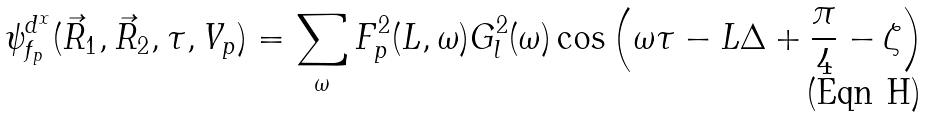<formula> <loc_0><loc_0><loc_500><loc_500>\psi _ { f _ { p } } ^ { d ^ { x } } ( \vec { R } _ { 1 } , \vec { R } _ { 2 } , \tau , V _ { p } ) = \sum _ { \omega } F _ { p } ^ { 2 } ( L , \omega ) G _ { l } ^ { 2 } ( \omega ) \cos \left ( \omega \tau - L \Delta + \frac { \pi } { 4 } - \zeta \right )</formula> 